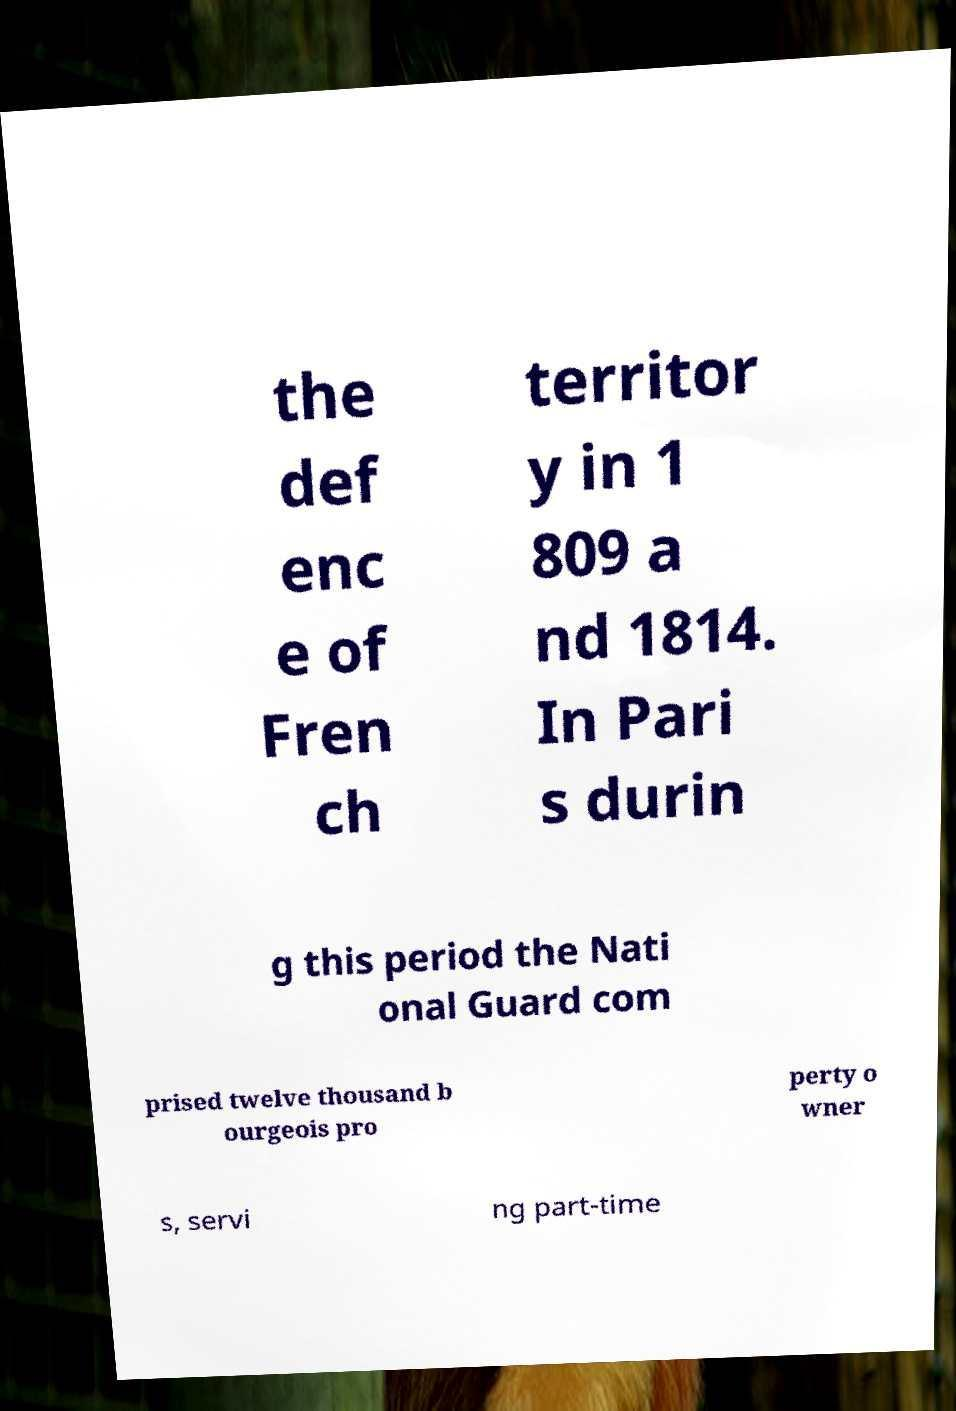Could you extract and type out the text from this image? the def enc e of Fren ch territor y in 1 809 a nd 1814. In Pari s durin g this period the Nati onal Guard com prised twelve thousand b ourgeois pro perty o wner s, servi ng part-time 